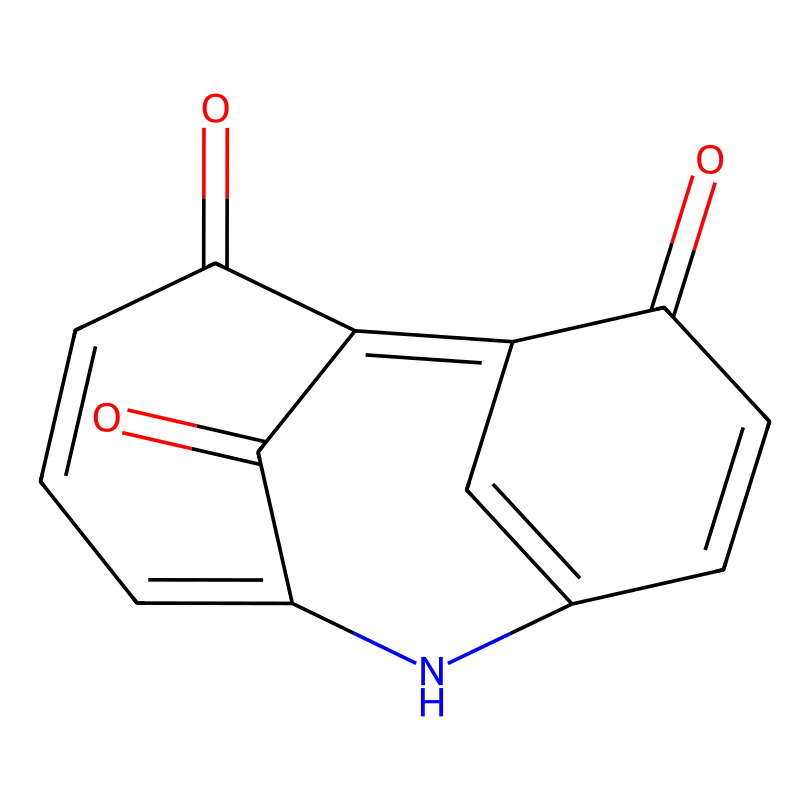What is the molecular formula of indigo? To determine the molecular formula, we need to count the number of each type of atom present in the chemical structure. In the structure represented by the SMILES provided, there are 16 carbon (C) atoms, 10 hydrogen (H) atoms, and 2 nitrogen (N) atoms along with 2 oxygen (O) atoms. Therefore, the molecular formula is C16H10N2O2.
Answer: C16H10N2O2 How many rings are present in the indigo structure? By analyzing the SMILES representation, we can observe that there are two distinct cyclical arrangements in the structure, specifically a benzene ring as well as another cyclic arrangement formed by different atoms. Counting them, we find that there are 2 rings present in the indigo molecule.
Answer: 2 What type of bonding is primarily present in indigo? The structure of indigo primarily features covalent bonds, as evidenced by the connections between carbon, nitrogen, and oxygen atoms. This type of bonding is typical for organic compounds, which include molecular structures like indigo.
Answer: covalent How many nitrogen atoms are part of the indigo molecule? A close examination of the molecule based on the SMILES notation shows that there are 2 nitrogen atoms appearing in the structure. This can be confirmed by locating the 'N' symbols in the representation.
Answer: 2 Is indigo a coordination compound? Indigo does not possess the characteristics of a coordination compound since it does not have a central metal atom surrounded by ligands. It contains only carbon, hydrogen, nitrogen, and oxygen in its structure without any metal center.
Answer: No 